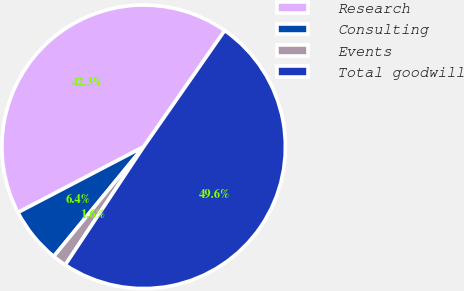<chart> <loc_0><loc_0><loc_500><loc_500><pie_chart><fcel>Research<fcel>Consulting<fcel>Events<fcel>Total goodwill<nl><fcel>42.35%<fcel>6.41%<fcel>1.6%<fcel>49.64%<nl></chart> 